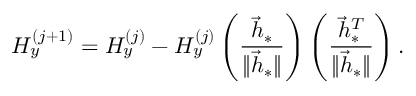<formula> <loc_0><loc_0><loc_500><loc_500>H _ { y } ^ { ( j + 1 ) } = H _ { y } ^ { ( j ) } - H _ { y } ^ { ( j ) } \left ( \frac { \vec { h } _ { \ast } } { \| \vec { h } _ { \ast } \| } \right ) \left ( \frac { \vec { h } _ { \ast } ^ { T } } { \| \vec { h } _ { \ast } \| } \right ) .</formula> 